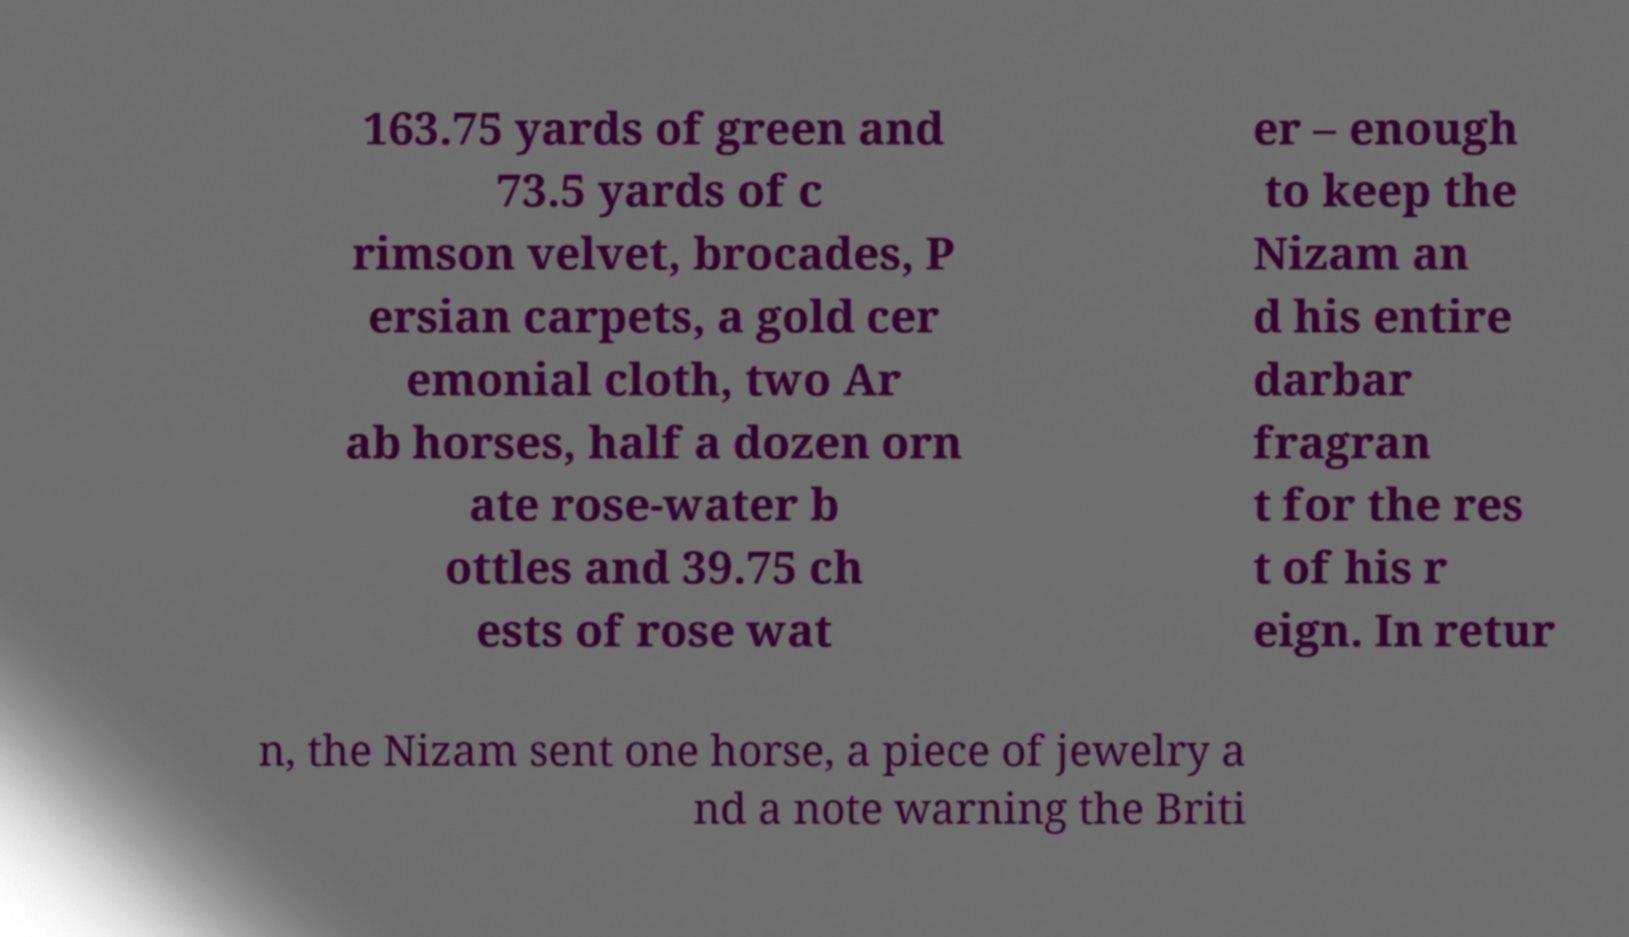For documentation purposes, I need the text within this image transcribed. Could you provide that? 163.75 yards of green and 73.5 yards of c rimson velvet, brocades, P ersian carpets, a gold cer emonial cloth, two Ar ab horses, half a dozen orn ate rose-water b ottles and 39.75 ch ests of rose wat er – enough to keep the Nizam an d his entire darbar fragran t for the res t of his r eign. In retur n, the Nizam sent one horse, a piece of jewelry a nd a note warning the Briti 